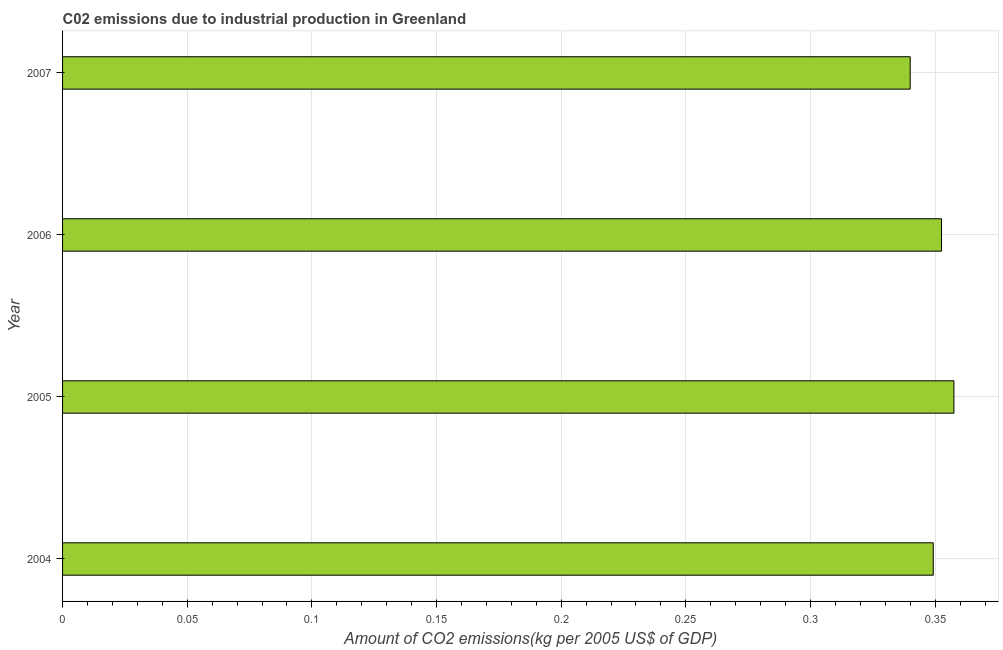Does the graph contain any zero values?
Your response must be concise. No. What is the title of the graph?
Offer a terse response. C02 emissions due to industrial production in Greenland. What is the label or title of the X-axis?
Your answer should be compact. Amount of CO2 emissions(kg per 2005 US$ of GDP). What is the label or title of the Y-axis?
Offer a terse response. Year. What is the amount of co2 emissions in 2004?
Your answer should be very brief. 0.35. Across all years, what is the maximum amount of co2 emissions?
Your answer should be compact. 0.36. Across all years, what is the minimum amount of co2 emissions?
Provide a succinct answer. 0.34. In which year was the amount of co2 emissions minimum?
Make the answer very short. 2007. What is the sum of the amount of co2 emissions?
Offer a terse response. 1.4. What is the difference between the amount of co2 emissions in 2004 and 2005?
Offer a very short reply. -0.01. What is the average amount of co2 emissions per year?
Your response must be concise. 0.35. What is the median amount of co2 emissions?
Make the answer very short. 0.35. What is the ratio of the amount of co2 emissions in 2004 to that in 2006?
Provide a succinct answer. 0.99. What is the difference between the highest and the second highest amount of co2 emissions?
Give a very brief answer. 0.01. Is the sum of the amount of co2 emissions in 2005 and 2006 greater than the maximum amount of co2 emissions across all years?
Ensure brevity in your answer.  Yes. What is the difference between the highest and the lowest amount of co2 emissions?
Provide a succinct answer. 0.02. In how many years, is the amount of co2 emissions greater than the average amount of co2 emissions taken over all years?
Offer a terse response. 2. How many bars are there?
Provide a succinct answer. 4. How many years are there in the graph?
Provide a succinct answer. 4. Are the values on the major ticks of X-axis written in scientific E-notation?
Give a very brief answer. No. What is the Amount of CO2 emissions(kg per 2005 US$ of GDP) in 2004?
Provide a succinct answer. 0.35. What is the Amount of CO2 emissions(kg per 2005 US$ of GDP) of 2005?
Your answer should be very brief. 0.36. What is the Amount of CO2 emissions(kg per 2005 US$ of GDP) in 2006?
Provide a succinct answer. 0.35. What is the Amount of CO2 emissions(kg per 2005 US$ of GDP) of 2007?
Provide a short and direct response. 0.34. What is the difference between the Amount of CO2 emissions(kg per 2005 US$ of GDP) in 2004 and 2005?
Give a very brief answer. -0.01. What is the difference between the Amount of CO2 emissions(kg per 2005 US$ of GDP) in 2004 and 2006?
Keep it short and to the point. -0. What is the difference between the Amount of CO2 emissions(kg per 2005 US$ of GDP) in 2004 and 2007?
Ensure brevity in your answer.  0.01. What is the difference between the Amount of CO2 emissions(kg per 2005 US$ of GDP) in 2005 and 2006?
Give a very brief answer. 0. What is the difference between the Amount of CO2 emissions(kg per 2005 US$ of GDP) in 2005 and 2007?
Give a very brief answer. 0.02. What is the difference between the Amount of CO2 emissions(kg per 2005 US$ of GDP) in 2006 and 2007?
Your answer should be very brief. 0.01. What is the ratio of the Amount of CO2 emissions(kg per 2005 US$ of GDP) in 2004 to that in 2005?
Give a very brief answer. 0.98. What is the ratio of the Amount of CO2 emissions(kg per 2005 US$ of GDP) in 2004 to that in 2006?
Your answer should be very brief. 0.99. What is the ratio of the Amount of CO2 emissions(kg per 2005 US$ of GDP) in 2005 to that in 2006?
Give a very brief answer. 1.01. What is the ratio of the Amount of CO2 emissions(kg per 2005 US$ of GDP) in 2005 to that in 2007?
Offer a very short reply. 1.05. What is the ratio of the Amount of CO2 emissions(kg per 2005 US$ of GDP) in 2006 to that in 2007?
Offer a terse response. 1.04. 